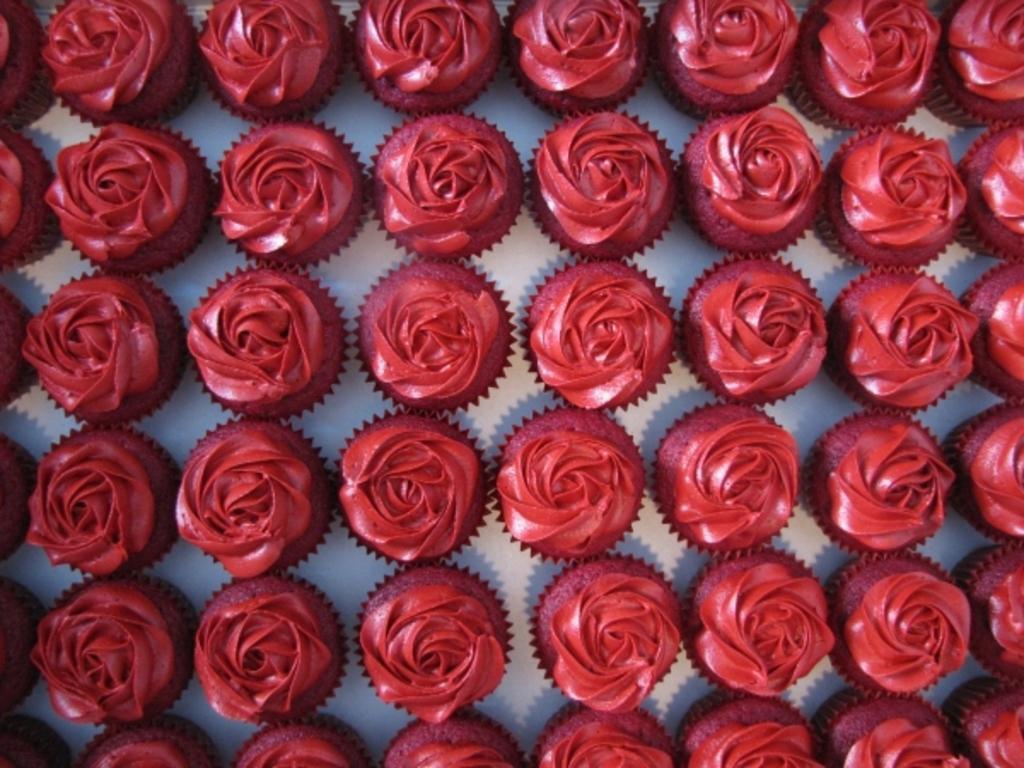How would you summarize this image in a sentence or two? In this picture we can see some cupcakes, on which we can see cream. 